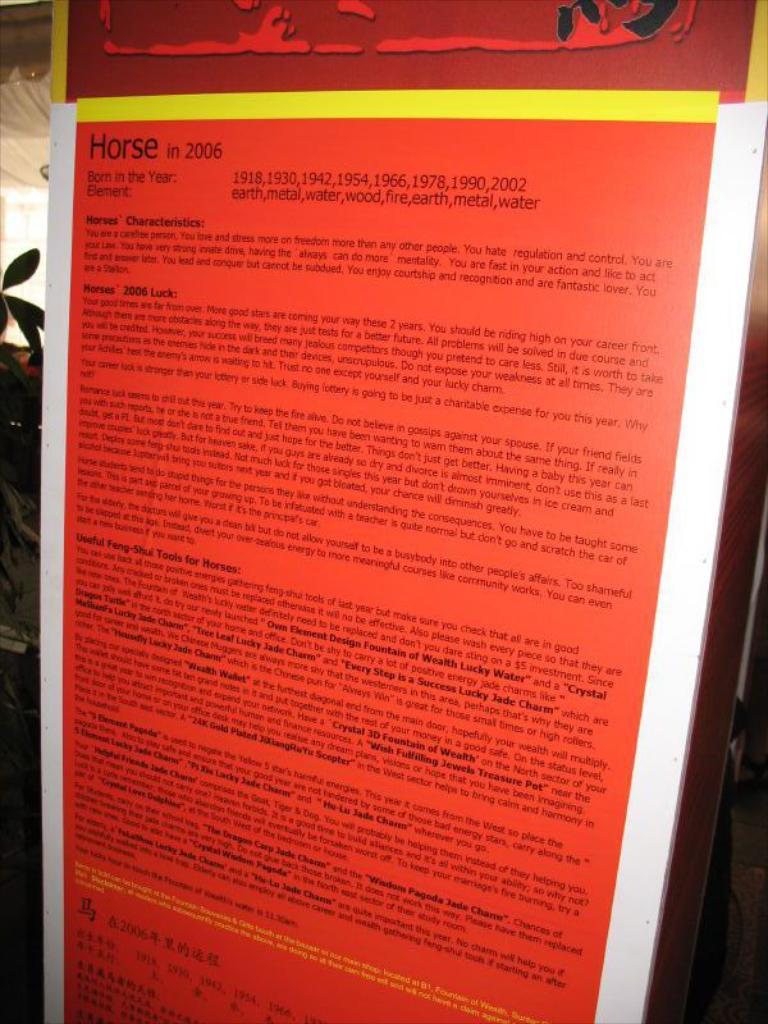<image>
Give a short and clear explanation of the subsequent image. A red poster about horses which explains horse characteristics. 